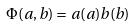Convert formula to latex. <formula><loc_0><loc_0><loc_500><loc_500>\Phi ( a , b ) = a ( a ) b ( b )</formula> 